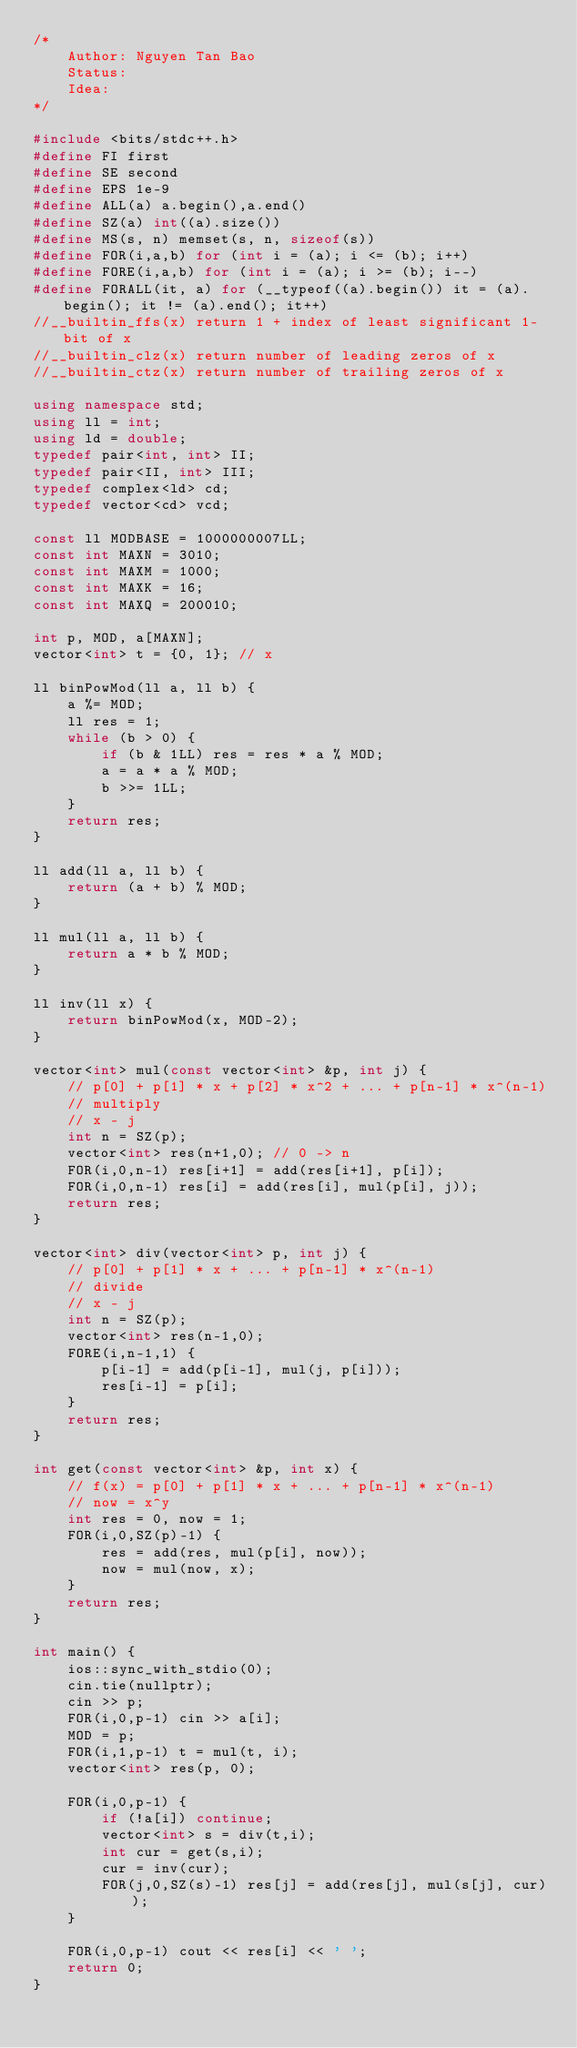<code> <loc_0><loc_0><loc_500><loc_500><_C++_>/*
    Author: Nguyen Tan Bao
    Status:
    Idea:
*/

#include <bits/stdc++.h>
#define FI first
#define SE second
#define EPS 1e-9
#define ALL(a) a.begin(),a.end()
#define SZ(a) int((a).size())
#define MS(s, n) memset(s, n, sizeof(s))
#define FOR(i,a,b) for (int i = (a); i <= (b); i++)
#define FORE(i,a,b) for (int i = (a); i >= (b); i--)
#define FORALL(it, a) for (__typeof((a).begin()) it = (a).begin(); it != (a).end(); it++)
//__builtin_ffs(x) return 1 + index of least significant 1-bit of x
//__builtin_clz(x) return number of leading zeros of x
//__builtin_ctz(x) return number of trailing zeros of x

using namespace std;
using ll = int;
using ld = double;
typedef pair<int, int> II;
typedef pair<II, int> III;
typedef complex<ld> cd;
typedef vector<cd> vcd;

const ll MODBASE = 1000000007LL;
const int MAXN = 3010;
const int MAXM = 1000;
const int MAXK = 16;
const int MAXQ = 200010;

int p, MOD, a[MAXN];
vector<int> t = {0, 1}; // x

ll binPowMod(ll a, ll b) {
    a %= MOD;
    ll res = 1;
    while (b > 0) {
        if (b & 1LL) res = res * a % MOD;
        a = a * a % MOD;
        b >>= 1LL;
    }
    return res;
}

ll add(ll a, ll b) {
    return (a + b) % MOD;
}

ll mul(ll a, ll b) {
    return a * b % MOD;
}

ll inv(ll x) {
    return binPowMod(x, MOD-2);
}

vector<int> mul(const vector<int> &p, int j) {
    // p[0] + p[1] * x + p[2] * x^2 + ... + p[n-1] * x^(n-1)
    // multiply
    // x - j
    int n = SZ(p);
    vector<int> res(n+1,0); // 0 -> n
    FOR(i,0,n-1) res[i+1] = add(res[i+1], p[i]);
    FOR(i,0,n-1) res[i] = add(res[i], mul(p[i], j));
    return res;
}

vector<int> div(vector<int> p, int j) {
    // p[0] + p[1] * x + ... + p[n-1] * x^(n-1)
    // divide
    // x - j
    int n = SZ(p);
    vector<int> res(n-1,0);
    FORE(i,n-1,1) {
        p[i-1] = add(p[i-1], mul(j, p[i]));
        res[i-1] = p[i];
    }
    return res;
}

int get(const vector<int> &p, int x) {
    // f(x) = p[0] + p[1] * x + ... + p[n-1] * x^(n-1)
    // now = x^y
    int res = 0, now = 1;
    FOR(i,0,SZ(p)-1) {
        res = add(res, mul(p[i], now));
        now = mul(now, x);
    }
    return res;
}

int main() {
    ios::sync_with_stdio(0);
    cin.tie(nullptr);
    cin >> p;
    FOR(i,0,p-1) cin >> a[i];
    MOD = p;
    FOR(i,1,p-1) t = mul(t, i);
    vector<int> res(p, 0);

    FOR(i,0,p-1) {
        if (!a[i]) continue;
        vector<int> s = div(t,i);
        int cur = get(s,i);
        cur = inv(cur);
        FOR(j,0,SZ(s)-1) res[j] = add(res[j], mul(s[j], cur));
    }

    FOR(i,0,p-1) cout << res[i] << ' ';
    return 0;
}
</code> 